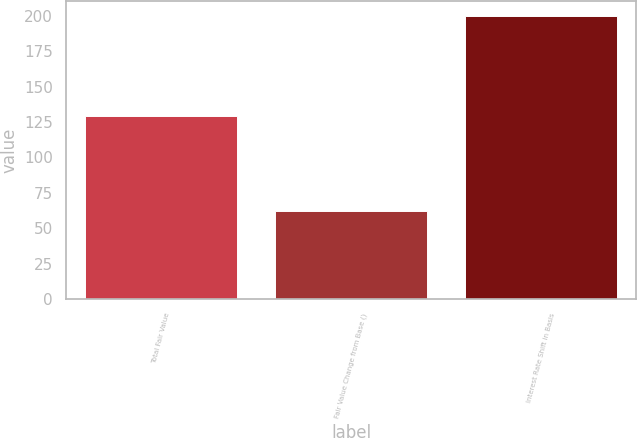<chart> <loc_0><loc_0><loc_500><loc_500><bar_chart><fcel>Total Fair Value<fcel>Fair Value Change from Base ()<fcel>Interest Rate Shift in Basis<nl><fcel>129<fcel>62.3<fcel>200<nl></chart> 